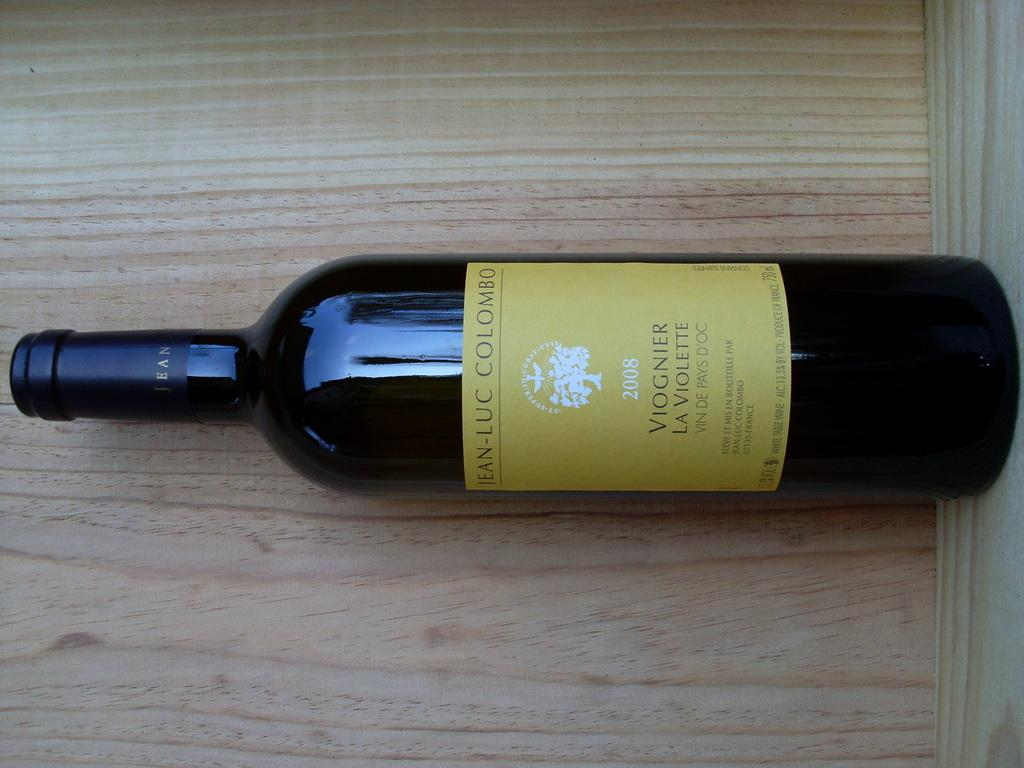<image>
Give a short and clear explanation of the subsequent image. A bottle with a yellow label says Jean Luc Colombo and 2008. 